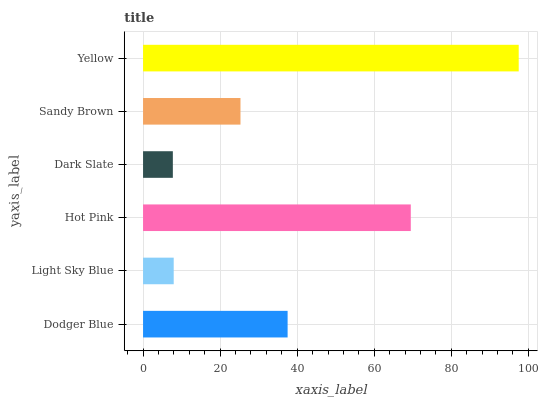Is Dark Slate the minimum?
Answer yes or no. Yes. Is Yellow the maximum?
Answer yes or no. Yes. Is Light Sky Blue the minimum?
Answer yes or no. No. Is Light Sky Blue the maximum?
Answer yes or no. No. Is Dodger Blue greater than Light Sky Blue?
Answer yes or no. Yes. Is Light Sky Blue less than Dodger Blue?
Answer yes or no. Yes. Is Light Sky Blue greater than Dodger Blue?
Answer yes or no. No. Is Dodger Blue less than Light Sky Blue?
Answer yes or no. No. Is Dodger Blue the high median?
Answer yes or no. Yes. Is Sandy Brown the low median?
Answer yes or no. Yes. Is Dark Slate the high median?
Answer yes or no. No. Is Light Sky Blue the low median?
Answer yes or no. No. 